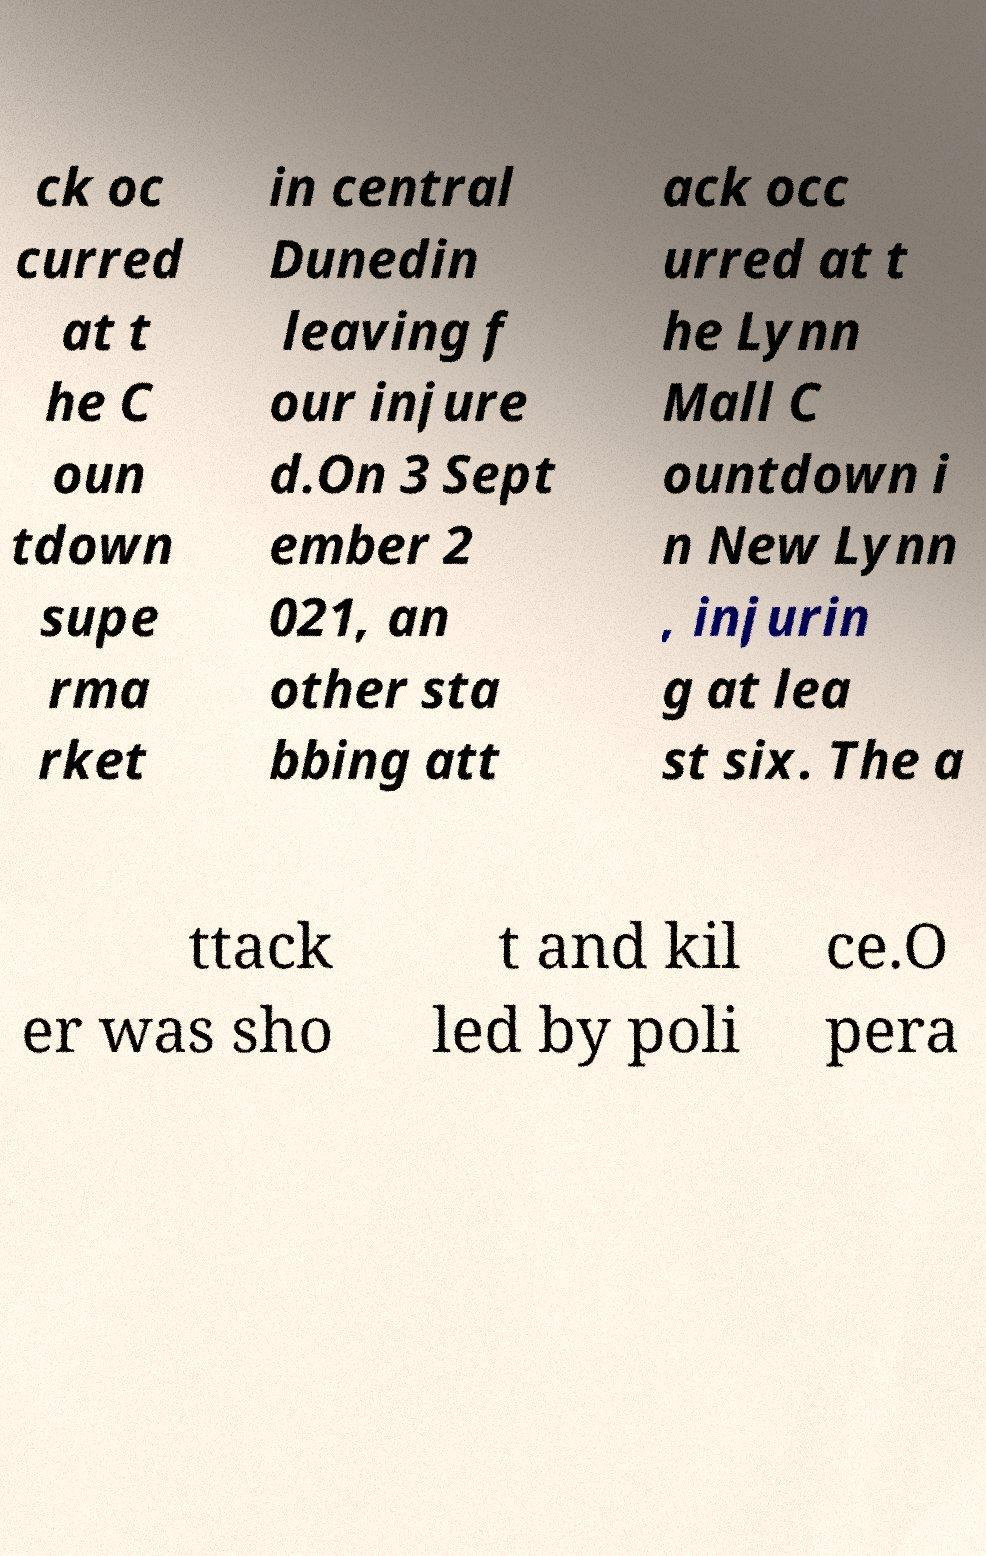Please identify and transcribe the text found in this image. ck oc curred at t he C oun tdown supe rma rket in central Dunedin leaving f our injure d.On 3 Sept ember 2 021, an other sta bbing att ack occ urred at t he Lynn Mall C ountdown i n New Lynn , injurin g at lea st six. The a ttack er was sho t and kil led by poli ce.O pera 